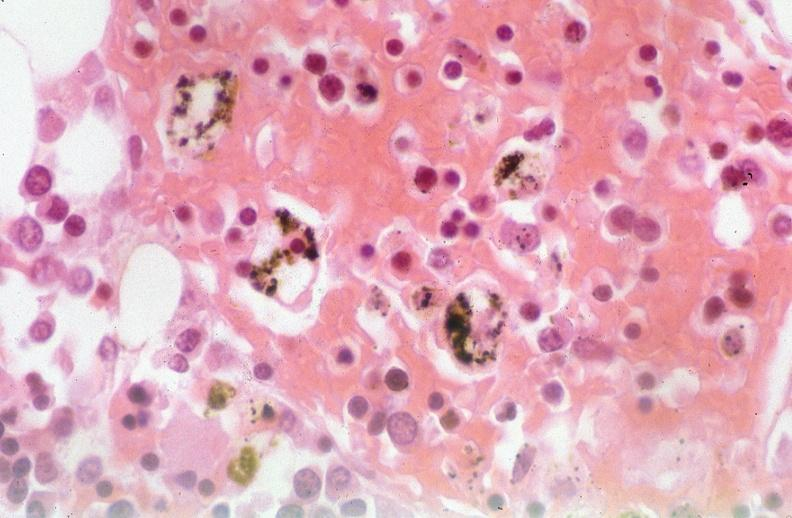does this image show pleura, talc reaction?
Answer the question using a single word or phrase. Yes 